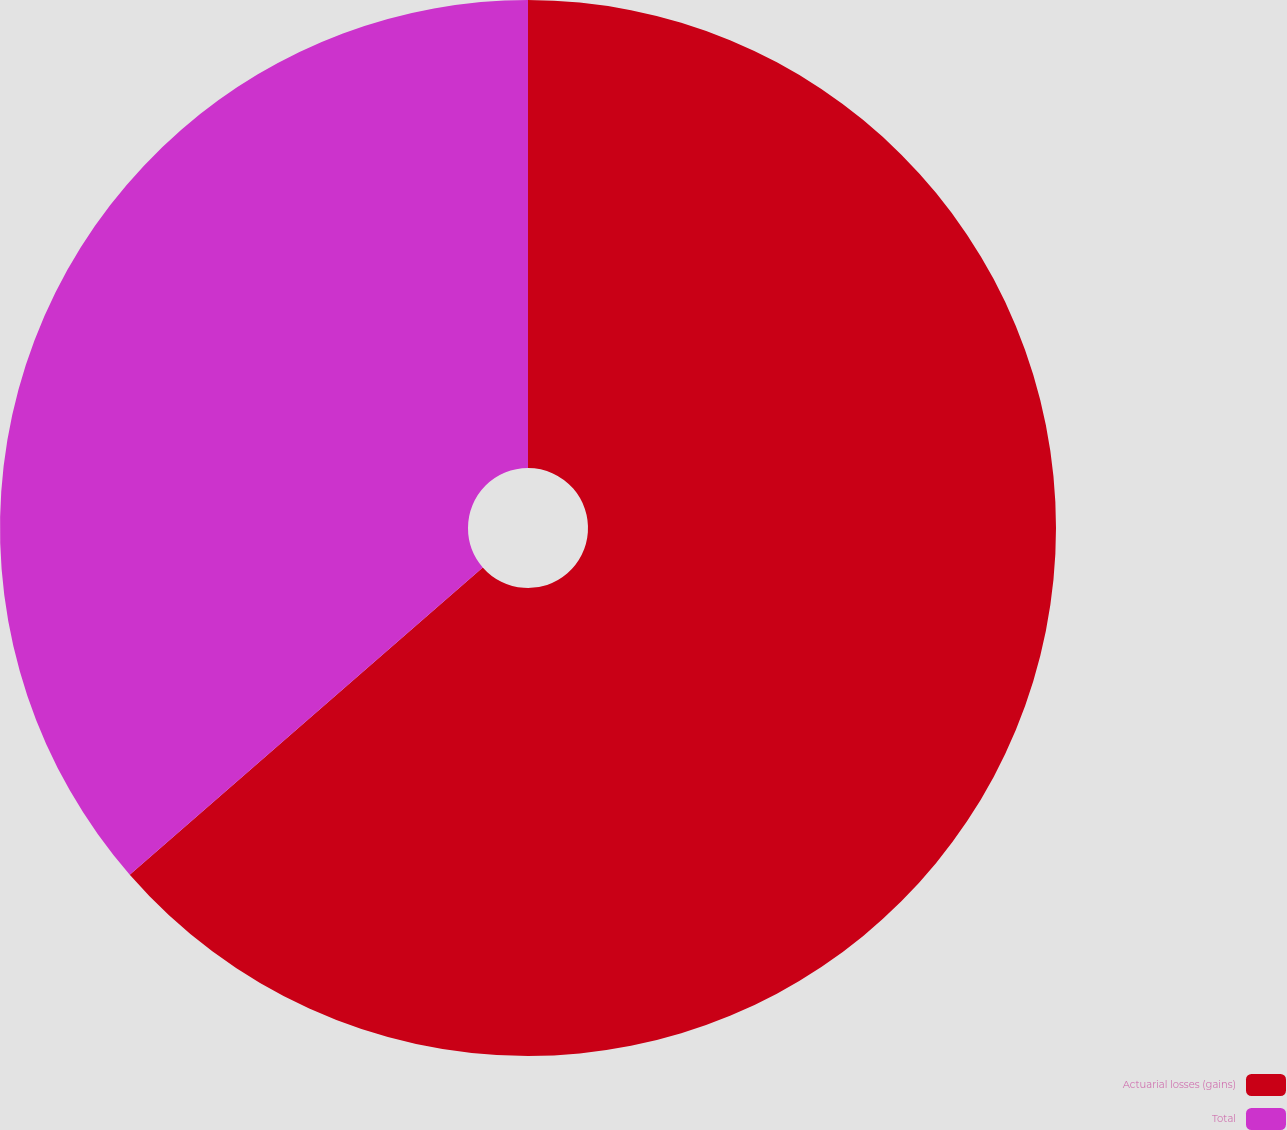<chart> <loc_0><loc_0><loc_500><loc_500><pie_chart><fcel>Actuarial losses (gains)<fcel>Total<nl><fcel>63.6%<fcel>36.4%<nl></chart> 